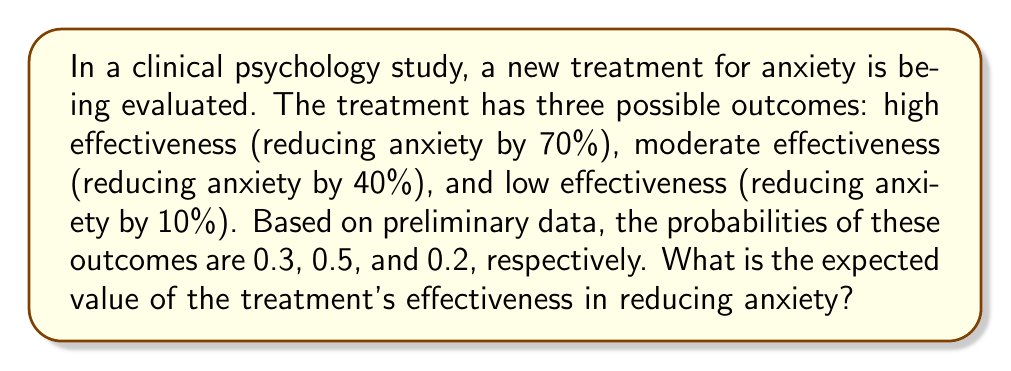Can you solve this math problem? To solve this problem, we need to follow these steps:

1. Identify the possible outcomes and their probabilities:
   - High effectiveness (70% reduction): $p_1 = 0.3$
   - Moderate effectiveness (40% reduction): $p_2 = 0.5$
   - Low effectiveness (10% reduction): $p_3 = 0.2$

2. Calculate the expected value using the formula:
   $$E(X) = \sum_{i=1}^n x_i \cdot p_i$$
   Where $x_i$ is the outcome value and $p_i$ is its probability.

3. Substitute the values:
   $$E(X) = (0.70 \cdot 0.3) + (0.40 \cdot 0.5) + (0.10 \cdot 0.2)$$

4. Perform the calculations:
   $$E(X) = 0.21 + 0.20 + 0.02$$

5. Sum up the results:
   $$E(X) = 0.43$$

Therefore, the expected value of the treatment's effectiveness in reducing anxiety is 0.43 or 43%.
Answer: 43% 